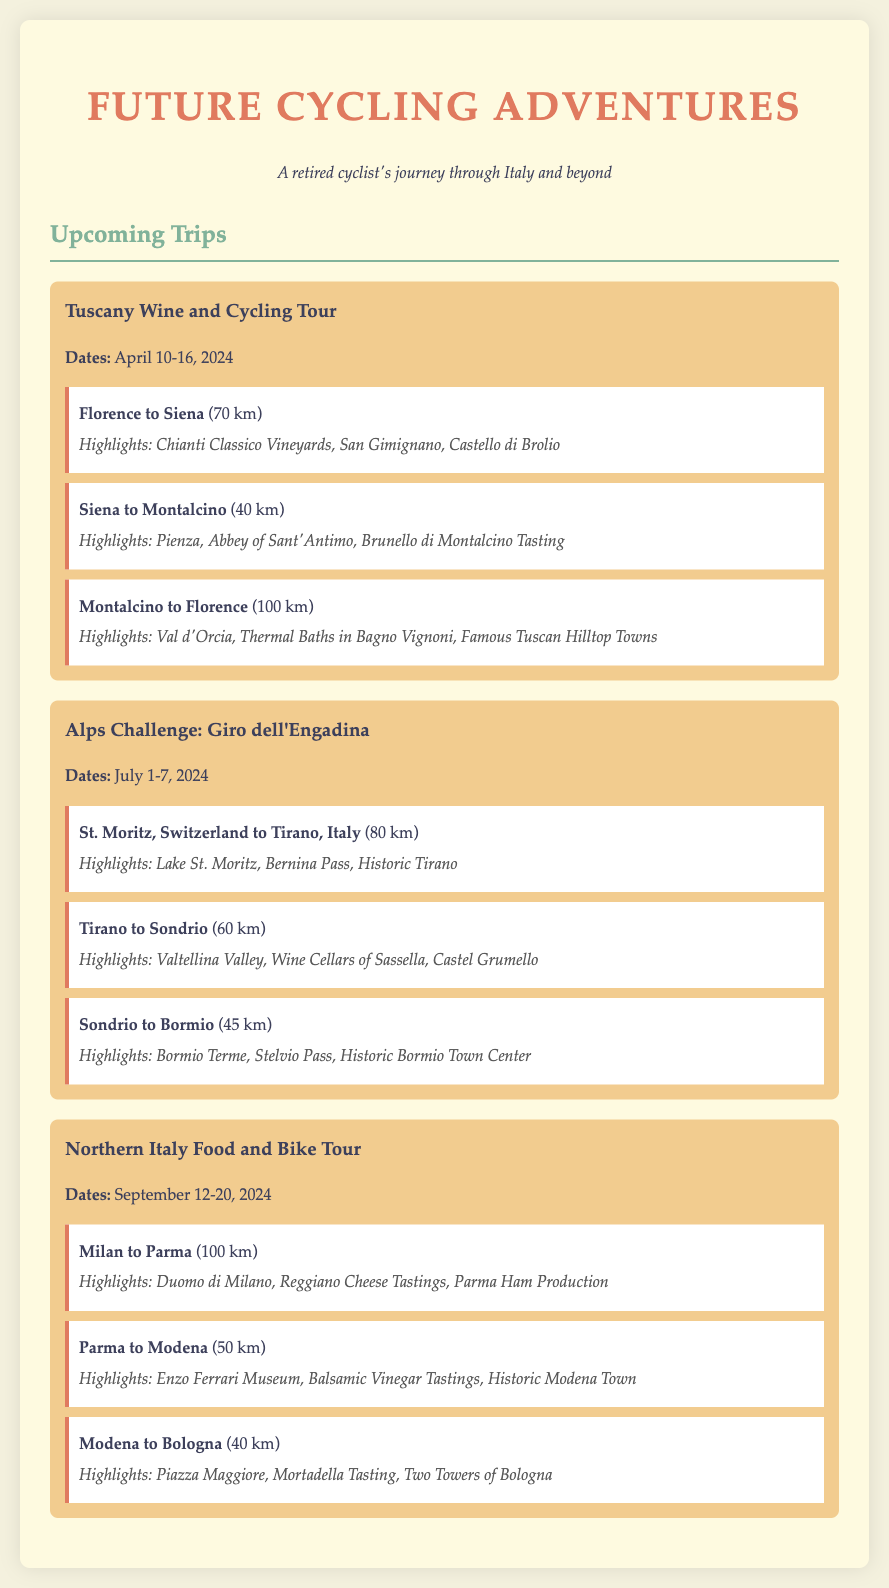What is the first trip listed? The first trip listed in the document is the "Tuscany Wine and Cycling Tour."
Answer: Tuscany Wine and Cycling Tour What are the dates for the Alps Challenge? The dates for the Alps Challenge are specified in the document as July 1-7, 2024.
Answer: July 1-7, 2024 How many kilometers is the route from Milan to Parma? The distance for the route from Milan to Parma is stated in the document as 100 km.
Answer: 100 km What is one of the points of interest for the Siena to Montalcino route? One of the points of interest for this route listed in the document is "Brunello di Montalcino Tasting."
Answer: Brunello di Montalcino Tasting Which highlight is mentioned for the Tirano to Sondrio leg? The highlight mentioned for the Tirano to Sondrio leg is "Wine Cellars of Sassella."
Answer: Wine Cellars of Sassella What is the total distance of the first trip? The total distance of the first trip can be calculated from the listed segments: 70 km + 40 km + 100 km = 210 km.
Answer: 210 km How many routes are detailed in the Northern Italy Food and Bike Tour? The document details three routes in the Northern Italy Food and Bike Tour.
Answer: Three routes What is the color scheme used for the document background? The background colors in the document are specified as a light tan and off-white.
Answer: Light tan and off-white 